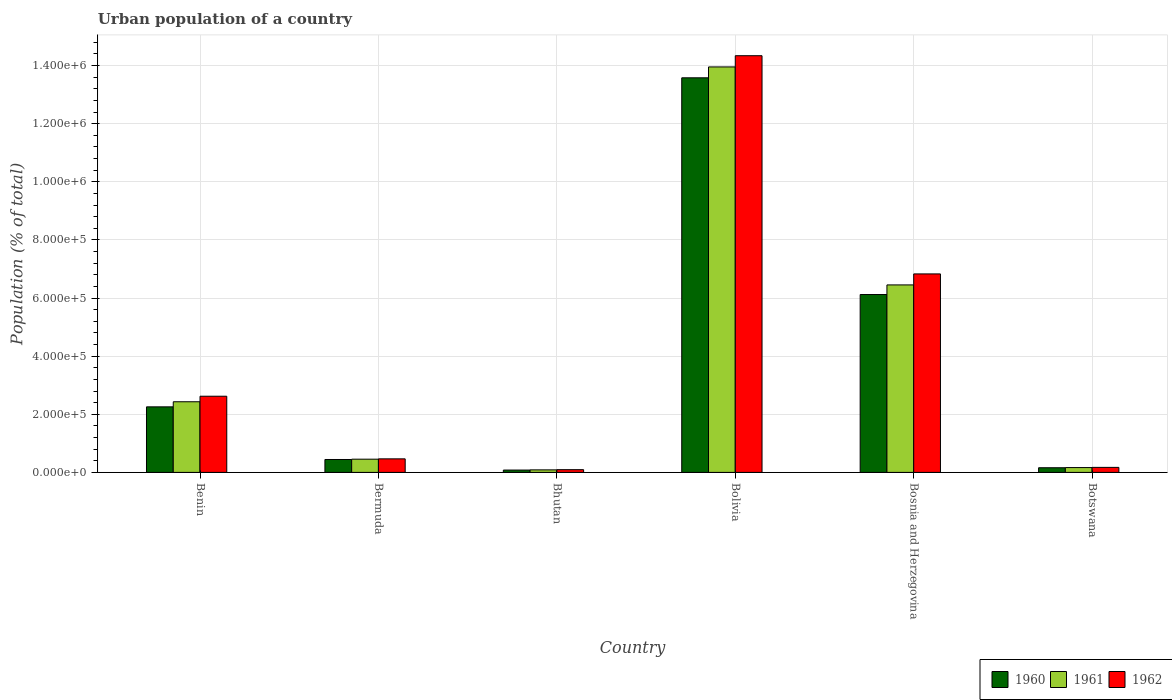Are the number of bars per tick equal to the number of legend labels?
Your answer should be very brief. Yes. Are the number of bars on each tick of the X-axis equal?
Offer a terse response. Yes. What is the label of the 5th group of bars from the left?
Your response must be concise. Bosnia and Herzegovina. In how many cases, is the number of bars for a given country not equal to the number of legend labels?
Provide a succinct answer. 0. What is the urban population in 1962 in Bhutan?
Keep it short and to the point. 9386. Across all countries, what is the maximum urban population in 1961?
Your answer should be compact. 1.40e+06. Across all countries, what is the minimum urban population in 1962?
Give a very brief answer. 9386. In which country was the urban population in 1960 maximum?
Ensure brevity in your answer.  Bolivia. In which country was the urban population in 1962 minimum?
Offer a terse response. Bhutan. What is the total urban population in 1961 in the graph?
Your answer should be compact. 2.35e+06. What is the difference between the urban population in 1962 in Bermuda and that in Botswana?
Your answer should be compact. 2.94e+04. What is the difference between the urban population in 1962 in Bolivia and the urban population in 1960 in Bosnia and Herzegovina?
Your answer should be compact. 8.22e+05. What is the average urban population in 1961 per country?
Your response must be concise. 3.92e+05. What is the difference between the urban population of/in 1961 and urban population of/in 1960 in Bolivia?
Make the answer very short. 3.74e+04. What is the ratio of the urban population in 1960 in Bermuda to that in Botswana?
Your answer should be very brief. 2.77. Is the difference between the urban population in 1961 in Benin and Bermuda greater than the difference between the urban population in 1960 in Benin and Bermuda?
Your response must be concise. Yes. What is the difference between the highest and the second highest urban population in 1960?
Offer a very short reply. -1.13e+06. What is the difference between the highest and the lowest urban population in 1961?
Your answer should be compact. 1.39e+06. Is the sum of the urban population in 1961 in Bermuda and Bolivia greater than the maximum urban population in 1960 across all countries?
Provide a succinct answer. Yes. Is it the case that in every country, the sum of the urban population in 1962 and urban population in 1961 is greater than the urban population in 1960?
Your response must be concise. Yes. Are all the bars in the graph horizontal?
Make the answer very short. No. How many countries are there in the graph?
Give a very brief answer. 6. What is the difference between two consecutive major ticks on the Y-axis?
Provide a short and direct response. 2.00e+05. Are the values on the major ticks of Y-axis written in scientific E-notation?
Ensure brevity in your answer.  Yes. Does the graph contain any zero values?
Your response must be concise. No. How many legend labels are there?
Ensure brevity in your answer.  3. What is the title of the graph?
Your response must be concise. Urban population of a country. What is the label or title of the Y-axis?
Keep it short and to the point. Population (% of total). What is the Population (% of total) of 1960 in Benin?
Make the answer very short. 2.26e+05. What is the Population (% of total) of 1961 in Benin?
Make the answer very short. 2.43e+05. What is the Population (% of total) in 1962 in Benin?
Keep it short and to the point. 2.62e+05. What is the Population (% of total) of 1960 in Bermuda?
Offer a terse response. 4.44e+04. What is the Population (% of total) of 1961 in Bermuda?
Make the answer very short. 4.55e+04. What is the Population (% of total) in 1962 in Bermuda?
Make the answer very short. 4.66e+04. What is the Population (% of total) of 1960 in Bhutan?
Ensure brevity in your answer.  8059. What is the Population (% of total) in 1961 in Bhutan?
Keep it short and to the point. 8695. What is the Population (% of total) of 1962 in Bhutan?
Your response must be concise. 9386. What is the Population (% of total) of 1960 in Bolivia?
Keep it short and to the point. 1.36e+06. What is the Population (% of total) in 1961 in Bolivia?
Your answer should be compact. 1.40e+06. What is the Population (% of total) in 1962 in Bolivia?
Provide a succinct answer. 1.43e+06. What is the Population (% of total) in 1960 in Bosnia and Herzegovina?
Ensure brevity in your answer.  6.12e+05. What is the Population (% of total) in 1961 in Bosnia and Herzegovina?
Provide a short and direct response. 6.45e+05. What is the Population (% of total) in 1962 in Bosnia and Herzegovina?
Make the answer very short. 6.83e+05. What is the Population (% of total) in 1960 in Botswana?
Your response must be concise. 1.60e+04. What is the Population (% of total) of 1961 in Botswana?
Offer a very short reply. 1.66e+04. What is the Population (% of total) in 1962 in Botswana?
Offer a terse response. 1.72e+04. Across all countries, what is the maximum Population (% of total) of 1960?
Provide a succinct answer. 1.36e+06. Across all countries, what is the maximum Population (% of total) of 1961?
Provide a succinct answer. 1.40e+06. Across all countries, what is the maximum Population (% of total) of 1962?
Make the answer very short. 1.43e+06. Across all countries, what is the minimum Population (% of total) of 1960?
Provide a short and direct response. 8059. Across all countries, what is the minimum Population (% of total) in 1961?
Offer a terse response. 8695. Across all countries, what is the minimum Population (% of total) in 1962?
Offer a terse response. 9386. What is the total Population (% of total) in 1960 in the graph?
Make the answer very short. 2.26e+06. What is the total Population (% of total) in 1961 in the graph?
Ensure brevity in your answer.  2.35e+06. What is the total Population (% of total) of 1962 in the graph?
Offer a very short reply. 2.45e+06. What is the difference between the Population (% of total) in 1960 in Benin and that in Bermuda?
Your answer should be very brief. 1.81e+05. What is the difference between the Population (% of total) of 1961 in Benin and that in Bermuda?
Provide a short and direct response. 1.98e+05. What is the difference between the Population (% of total) in 1962 in Benin and that in Bermuda?
Make the answer very short. 2.15e+05. What is the difference between the Population (% of total) of 1960 in Benin and that in Bhutan?
Ensure brevity in your answer.  2.17e+05. What is the difference between the Population (% of total) of 1961 in Benin and that in Bhutan?
Offer a terse response. 2.34e+05. What is the difference between the Population (% of total) of 1962 in Benin and that in Bhutan?
Provide a succinct answer. 2.53e+05. What is the difference between the Population (% of total) in 1960 in Benin and that in Bolivia?
Provide a succinct answer. -1.13e+06. What is the difference between the Population (% of total) of 1961 in Benin and that in Bolivia?
Give a very brief answer. -1.15e+06. What is the difference between the Population (% of total) of 1962 in Benin and that in Bolivia?
Provide a short and direct response. -1.17e+06. What is the difference between the Population (% of total) of 1960 in Benin and that in Bosnia and Herzegovina?
Your answer should be compact. -3.87e+05. What is the difference between the Population (% of total) of 1961 in Benin and that in Bosnia and Herzegovina?
Your answer should be very brief. -4.02e+05. What is the difference between the Population (% of total) of 1962 in Benin and that in Bosnia and Herzegovina?
Keep it short and to the point. -4.21e+05. What is the difference between the Population (% of total) in 1960 in Benin and that in Botswana?
Your answer should be very brief. 2.09e+05. What is the difference between the Population (% of total) of 1961 in Benin and that in Botswana?
Your answer should be compact. 2.26e+05. What is the difference between the Population (% of total) of 1962 in Benin and that in Botswana?
Make the answer very short. 2.45e+05. What is the difference between the Population (% of total) in 1960 in Bermuda and that in Bhutan?
Provide a short and direct response. 3.63e+04. What is the difference between the Population (% of total) of 1961 in Bermuda and that in Bhutan?
Ensure brevity in your answer.  3.68e+04. What is the difference between the Population (% of total) in 1962 in Bermuda and that in Bhutan?
Give a very brief answer. 3.72e+04. What is the difference between the Population (% of total) in 1960 in Bermuda and that in Bolivia?
Provide a succinct answer. -1.31e+06. What is the difference between the Population (% of total) in 1961 in Bermuda and that in Bolivia?
Your answer should be very brief. -1.35e+06. What is the difference between the Population (% of total) of 1962 in Bermuda and that in Bolivia?
Your response must be concise. -1.39e+06. What is the difference between the Population (% of total) in 1960 in Bermuda and that in Bosnia and Herzegovina?
Provide a succinct answer. -5.68e+05. What is the difference between the Population (% of total) in 1961 in Bermuda and that in Bosnia and Herzegovina?
Your response must be concise. -6.00e+05. What is the difference between the Population (% of total) of 1962 in Bermuda and that in Bosnia and Herzegovina?
Offer a terse response. -6.36e+05. What is the difference between the Population (% of total) of 1960 in Bermuda and that in Botswana?
Keep it short and to the point. 2.84e+04. What is the difference between the Population (% of total) of 1961 in Bermuda and that in Botswana?
Your answer should be very brief. 2.89e+04. What is the difference between the Population (% of total) of 1962 in Bermuda and that in Botswana?
Make the answer very short. 2.94e+04. What is the difference between the Population (% of total) of 1960 in Bhutan and that in Bolivia?
Your answer should be very brief. -1.35e+06. What is the difference between the Population (% of total) of 1961 in Bhutan and that in Bolivia?
Your answer should be very brief. -1.39e+06. What is the difference between the Population (% of total) in 1962 in Bhutan and that in Bolivia?
Ensure brevity in your answer.  -1.42e+06. What is the difference between the Population (% of total) in 1960 in Bhutan and that in Bosnia and Herzegovina?
Provide a succinct answer. -6.04e+05. What is the difference between the Population (% of total) of 1961 in Bhutan and that in Bosnia and Herzegovina?
Your response must be concise. -6.36e+05. What is the difference between the Population (% of total) of 1962 in Bhutan and that in Bosnia and Herzegovina?
Give a very brief answer. -6.74e+05. What is the difference between the Population (% of total) in 1960 in Bhutan and that in Botswana?
Make the answer very short. -7976. What is the difference between the Population (% of total) in 1961 in Bhutan and that in Botswana?
Your answer should be very brief. -7923. What is the difference between the Population (% of total) in 1962 in Bhutan and that in Botswana?
Your response must be concise. -7851. What is the difference between the Population (% of total) in 1960 in Bolivia and that in Bosnia and Herzegovina?
Offer a terse response. 7.46e+05. What is the difference between the Population (% of total) in 1961 in Bolivia and that in Bosnia and Herzegovina?
Your answer should be compact. 7.50e+05. What is the difference between the Population (% of total) in 1962 in Bolivia and that in Bosnia and Herzegovina?
Your answer should be very brief. 7.51e+05. What is the difference between the Population (% of total) of 1960 in Bolivia and that in Botswana?
Your answer should be very brief. 1.34e+06. What is the difference between the Population (% of total) of 1961 in Bolivia and that in Botswana?
Your answer should be compact. 1.38e+06. What is the difference between the Population (% of total) in 1962 in Bolivia and that in Botswana?
Keep it short and to the point. 1.42e+06. What is the difference between the Population (% of total) of 1960 in Bosnia and Herzegovina and that in Botswana?
Keep it short and to the point. 5.96e+05. What is the difference between the Population (% of total) in 1961 in Bosnia and Herzegovina and that in Botswana?
Your response must be concise. 6.29e+05. What is the difference between the Population (% of total) in 1962 in Bosnia and Herzegovina and that in Botswana?
Ensure brevity in your answer.  6.66e+05. What is the difference between the Population (% of total) of 1960 in Benin and the Population (% of total) of 1961 in Bermuda?
Make the answer very short. 1.80e+05. What is the difference between the Population (% of total) of 1960 in Benin and the Population (% of total) of 1962 in Bermuda?
Provide a short and direct response. 1.79e+05. What is the difference between the Population (% of total) of 1961 in Benin and the Population (% of total) of 1962 in Bermuda?
Offer a very short reply. 1.96e+05. What is the difference between the Population (% of total) of 1960 in Benin and the Population (% of total) of 1961 in Bhutan?
Offer a very short reply. 2.17e+05. What is the difference between the Population (% of total) in 1960 in Benin and the Population (% of total) in 1962 in Bhutan?
Provide a short and direct response. 2.16e+05. What is the difference between the Population (% of total) of 1961 in Benin and the Population (% of total) of 1962 in Bhutan?
Make the answer very short. 2.34e+05. What is the difference between the Population (% of total) of 1960 in Benin and the Population (% of total) of 1961 in Bolivia?
Make the answer very short. -1.17e+06. What is the difference between the Population (% of total) in 1960 in Benin and the Population (% of total) in 1962 in Bolivia?
Keep it short and to the point. -1.21e+06. What is the difference between the Population (% of total) in 1961 in Benin and the Population (% of total) in 1962 in Bolivia?
Give a very brief answer. -1.19e+06. What is the difference between the Population (% of total) of 1960 in Benin and the Population (% of total) of 1961 in Bosnia and Herzegovina?
Your answer should be very brief. -4.20e+05. What is the difference between the Population (% of total) in 1960 in Benin and the Population (% of total) in 1962 in Bosnia and Herzegovina?
Keep it short and to the point. -4.57e+05. What is the difference between the Population (% of total) of 1961 in Benin and the Population (% of total) of 1962 in Bosnia and Herzegovina?
Keep it short and to the point. -4.40e+05. What is the difference between the Population (% of total) in 1960 in Benin and the Population (% of total) in 1961 in Botswana?
Your answer should be very brief. 2.09e+05. What is the difference between the Population (% of total) in 1960 in Benin and the Population (% of total) in 1962 in Botswana?
Offer a very short reply. 2.08e+05. What is the difference between the Population (% of total) in 1961 in Benin and the Population (% of total) in 1962 in Botswana?
Provide a succinct answer. 2.26e+05. What is the difference between the Population (% of total) of 1960 in Bermuda and the Population (% of total) of 1961 in Bhutan?
Give a very brief answer. 3.57e+04. What is the difference between the Population (% of total) in 1960 in Bermuda and the Population (% of total) in 1962 in Bhutan?
Make the answer very short. 3.50e+04. What is the difference between the Population (% of total) of 1961 in Bermuda and the Population (% of total) of 1962 in Bhutan?
Your response must be concise. 3.61e+04. What is the difference between the Population (% of total) in 1960 in Bermuda and the Population (% of total) in 1961 in Bolivia?
Your answer should be compact. -1.35e+06. What is the difference between the Population (% of total) of 1960 in Bermuda and the Population (% of total) of 1962 in Bolivia?
Keep it short and to the point. -1.39e+06. What is the difference between the Population (% of total) of 1961 in Bermuda and the Population (% of total) of 1962 in Bolivia?
Make the answer very short. -1.39e+06. What is the difference between the Population (% of total) in 1960 in Bermuda and the Population (% of total) in 1961 in Bosnia and Herzegovina?
Give a very brief answer. -6.01e+05. What is the difference between the Population (% of total) in 1960 in Bermuda and the Population (% of total) in 1962 in Bosnia and Herzegovina?
Offer a terse response. -6.39e+05. What is the difference between the Population (% of total) in 1961 in Bermuda and the Population (% of total) in 1962 in Bosnia and Herzegovina?
Ensure brevity in your answer.  -6.37e+05. What is the difference between the Population (% of total) in 1960 in Bermuda and the Population (% of total) in 1961 in Botswana?
Provide a succinct answer. 2.78e+04. What is the difference between the Population (% of total) in 1960 in Bermuda and the Population (% of total) in 1962 in Botswana?
Make the answer very short. 2.72e+04. What is the difference between the Population (% of total) in 1961 in Bermuda and the Population (% of total) in 1962 in Botswana?
Make the answer very short. 2.83e+04. What is the difference between the Population (% of total) in 1960 in Bhutan and the Population (% of total) in 1961 in Bolivia?
Offer a very short reply. -1.39e+06. What is the difference between the Population (% of total) of 1960 in Bhutan and the Population (% of total) of 1962 in Bolivia?
Make the answer very short. -1.43e+06. What is the difference between the Population (% of total) in 1961 in Bhutan and the Population (% of total) in 1962 in Bolivia?
Provide a short and direct response. -1.43e+06. What is the difference between the Population (% of total) in 1960 in Bhutan and the Population (% of total) in 1961 in Bosnia and Herzegovina?
Offer a very short reply. -6.37e+05. What is the difference between the Population (% of total) in 1960 in Bhutan and the Population (% of total) in 1962 in Bosnia and Herzegovina?
Make the answer very short. -6.75e+05. What is the difference between the Population (% of total) of 1961 in Bhutan and the Population (% of total) of 1962 in Bosnia and Herzegovina?
Your answer should be very brief. -6.74e+05. What is the difference between the Population (% of total) of 1960 in Bhutan and the Population (% of total) of 1961 in Botswana?
Give a very brief answer. -8559. What is the difference between the Population (% of total) of 1960 in Bhutan and the Population (% of total) of 1962 in Botswana?
Ensure brevity in your answer.  -9178. What is the difference between the Population (% of total) in 1961 in Bhutan and the Population (% of total) in 1962 in Botswana?
Keep it short and to the point. -8542. What is the difference between the Population (% of total) of 1960 in Bolivia and the Population (% of total) of 1961 in Bosnia and Herzegovina?
Your response must be concise. 7.13e+05. What is the difference between the Population (% of total) in 1960 in Bolivia and the Population (% of total) in 1962 in Bosnia and Herzegovina?
Your response must be concise. 6.75e+05. What is the difference between the Population (% of total) of 1961 in Bolivia and the Population (% of total) of 1962 in Bosnia and Herzegovina?
Your answer should be compact. 7.12e+05. What is the difference between the Population (% of total) in 1960 in Bolivia and the Population (% of total) in 1961 in Botswana?
Provide a succinct answer. 1.34e+06. What is the difference between the Population (% of total) of 1960 in Bolivia and the Population (% of total) of 1962 in Botswana?
Offer a very short reply. 1.34e+06. What is the difference between the Population (% of total) of 1961 in Bolivia and the Population (% of total) of 1962 in Botswana?
Offer a terse response. 1.38e+06. What is the difference between the Population (% of total) of 1960 in Bosnia and Herzegovina and the Population (% of total) of 1961 in Botswana?
Offer a terse response. 5.95e+05. What is the difference between the Population (% of total) of 1960 in Bosnia and Herzegovina and the Population (% of total) of 1962 in Botswana?
Give a very brief answer. 5.95e+05. What is the difference between the Population (% of total) of 1961 in Bosnia and Herzegovina and the Population (% of total) of 1962 in Botswana?
Provide a short and direct response. 6.28e+05. What is the average Population (% of total) of 1960 per country?
Your answer should be compact. 3.77e+05. What is the average Population (% of total) in 1961 per country?
Keep it short and to the point. 3.92e+05. What is the average Population (% of total) in 1962 per country?
Provide a succinct answer. 4.09e+05. What is the difference between the Population (% of total) in 1960 and Population (% of total) in 1961 in Benin?
Provide a short and direct response. -1.75e+04. What is the difference between the Population (% of total) of 1960 and Population (% of total) of 1962 in Benin?
Offer a very short reply. -3.66e+04. What is the difference between the Population (% of total) of 1961 and Population (% of total) of 1962 in Benin?
Offer a terse response. -1.90e+04. What is the difference between the Population (% of total) in 1960 and Population (% of total) in 1961 in Bermuda?
Your answer should be very brief. -1100. What is the difference between the Population (% of total) of 1960 and Population (% of total) of 1962 in Bermuda?
Provide a short and direct response. -2200. What is the difference between the Population (% of total) in 1961 and Population (% of total) in 1962 in Bermuda?
Offer a terse response. -1100. What is the difference between the Population (% of total) of 1960 and Population (% of total) of 1961 in Bhutan?
Offer a very short reply. -636. What is the difference between the Population (% of total) in 1960 and Population (% of total) in 1962 in Bhutan?
Give a very brief answer. -1327. What is the difference between the Population (% of total) of 1961 and Population (% of total) of 1962 in Bhutan?
Provide a short and direct response. -691. What is the difference between the Population (% of total) in 1960 and Population (% of total) in 1961 in Bolivia?
Your answer should be very brief. -3.74e+04. What is the difference between the Population (% of total) of 1960 and Population (% of total) of 1962 in Bolivia?
Offer a terse response. -7.60e+04. What is the difference between the Population (% of total) of 1961 and Population (% of total) of 1962 in Bolivia?
Your response must be concise. -3.86e+04. What is the difference between the Population (% of total) of 1960 and Population (% of total) of 1961 in Bosnia and Herzegovina?
Give a very brief answer. -3.31e+04. What is the difference between the Population (% of total) in 1960 and Population (% of total) in 1962 in Bosnia and Herzegovina?
Your response must be concise. -7.09e+04. What is the difference between the Population (% of total) of 1961 and Population (% of total) of 1962 in Bosnia and Herzegovina?
Provide a succinct answer. -3.78e+04. What is the difference between the Population (% of total) in 1960 and Population (% of total) in 1961 in Botswana?
Your answer should be compact. -583. What is the difference between the Population (% of total) of 1960 and Population (% of total) of 1962 in Botswana?
Provide a short and direct response. -1202. What is the difference between the Population (% of total) in 1961 and Population (% of total) in 1962 in Botswana?
Give a very brief answer. -619. What is the ratio of the Population (% of total) of 1960 in Benin to that in Bermuda?
Your answer should be very brief. 5.08. What is the ratio of the Population (% of total) in 1961 in Benin to that in Bermuda?
Give a very brief answer. 5.34. What is the ratio of the Population (% of total) in 1962 in Benin to that in Bermuda?
Keep it short and to the point. 5.62. What is the ratio of the Population (% of total) in 1960 in Benin to that in Bhutan?
Provide a short and direct response. 27.99. What is the ratio of the Population (% of total) of 1961 in Benin to that in Bhutan?
Ensure brevity in your answer.  27.95. What is the ratio of the Population (% of total) of 1962 in Benin to that in Bhutan?
Your answer should be very brief. 27.92. What is the ratio of the Population (% of total) in 1960 in Benin to that in Bolivia?
Make the answer very short. 0.17. What is the ratio of the Population (% of total) in 1961 in Benin to that in Bolivia?
Give a very brief answer. 0.17. What is the ratio of the Population (% of total) in 1962 in Benin to that in Bolivia?
Ensure brevity in your answer.  0.18. What is the ratio of the Population (% of total) of 1960 in Benin to that in Bosnia and Herzegovina?
Offer a very short reply. 0.37. What is the ratio of the Population (% of total) of 1961 in Benin to that in Bosnia and Herzegovina?
Your response must be concise. 0.38. What is the ratio of the Population (% of total) in 1962 in Benin to that in Bosnia and Herzegovina?
Offer a terse response. 0.38. What is the ratio of the Population (% of total) in 1960 in Benin to that in Botswana?
Provide a short and direct response. 14.06. What is the ratio of the Population (% of total) in 1961 in Benin to that in Botswana?
Offer a very short reply. 14.63. What is the ratio of the Population (% of total) in 1962 in Benin to that in Botswana?
Make the answer very short. 15.21. What is the ratio of the Population (% of total) of 1960 in Bermuda to that in Bhutan?
Give a very brief answer. 5.51. What is the ratio of the Population (% of total) of 1961 in Bermuda to that in Bhutan?
Your answer should be very brief. 5.23. What is the ratio of the Population (% of total) of 1962 in Bermuda to that in Bhutan?
Your response must be concise. 4.96. What is the ratio of the Population (% of total) of 1960 in Bermuda to that in Bolivia?
Keep it short and to the point. 0.03. What is the ratio of the Population (% of total) in 1961 in Bermuda to that in Bolivia?
Ensure brevity in your answer.  0.03. What is the ratio of the Population (% of total) in 1962 in Bermuda to that in Bolivia?
Make the answer very short. 0.03. What is the ratio of the Population (% of total) in 1960 in Bermuda to that in Bosnia and Herzegovina?
Provide a succinct answer. 0.07. What is the ratio of the Population (% of total) of 1961 in Bermuda to that in Bosnia and Herzegovina?
Your response must be concise. 0.07. What is the ratio of the Population (% of total) in 1962 in Bermuda to that in Bosnia and Herzegovina?
Give a very brief answer. 0.07. What is the ratio of the Population (% of total) in 1960 in Bermuda to that in Botswana?
Your answer should be compact. 2.77. What is the ratio of the Population (% of total) in 1961 in Bermuda to that in Botswana?
Your response must be concise. 2.74. What is the ratio of the Population (% of total) in 1962 in Bermuda to that in Botswana?
Keep it short and to the point. 2.7. What is the ratio of the Population (% of total) of 1960 in Bhutan to that in Bolivia?
Provide a succinct answer. 0.01. What is the ratio of the Population (% of total) of 1961 in Bhutan to that in Bolivia?
Your answer should be very brief. 0.01. What is the ratio of the Population (% of total) in 1962 in Bhutan to that in Bolivia?
Offer a very short reply. 0.01. What is the ratio of the Population (% of total) of 1960 in Bhutan to that in Bosnia and Herzegovina?
Your response must be concise. 0.01. What is the ratio of the Population (% of total) of 1961 in Bhutan to that in Bosnia and Herzegovina?
Provide a succinct answer. 0.01. What is the ratio of the Population (% of total) in 1962 in Bhutan to that in Bosnia and Herzegovina?
Offer a very short reply. 0.01. What is the ratio of the Population (% of total) of 1960 in Bhutan to that in Botswana?
Offer a terse response. 0.5. What is the ratio of the Population (% of total) in 1961 in Bhutan to that in Botswana?
Give a very brief answer. 0.52. What is the ratio of the Population (% of total) of 1962 in Bhutan to that in Botswana?
Your answer should be very brief. 0.54. What is the ratio of the Population (% of total) in 1960 in Bolivia to that in Bosnia and Herzegovina?
Your answer should be very brief. 2.22. What is the ratio of the Population (% of total) of 1961 in Bolivia to that in Bosnia and Herzegovina?
Your response must be concise. 2.16. What is the ratio of the Population (% of total) of 1962 in Bolivia to that in Bosnia and Herzegovina?
Give a very brief answer. 2.1. What is the ratio of the Population (% of total) in 1960 in Bolivia to that in Botswana?
Ensure brevity in your answer.  84.68. What is the ratio of the Population (% of total) of 1961 in Bolivia to that in Botswana?
Your response must be concise. 83.96. What is the ratio of the Population (% of total) of 1962 in Bolivia to that in Botswana?
Offer a terse response. 83.18. What is the ratio of the Population (% of total) in 1960 in Bosnia and Herzegovina to that in Botswana?
Offer a terse response. 38.17. What is the ratio of the Population (% of total) in 1961 in Bosnia and Herzegovina to that in Botswana?
Give a very brief answer. 38.82. What is the ratio of the Population (% of total) in 1962 in Bosnia and Herzegovina to that in Botswana?
Give a very brief answer. 39.62. What is the difference between the highest and the second highest Population (% of total) of 1960?
Make the answer very short. 7.46e+05. What is the difference between the highest and the second highest Population (% of total) of 1961?
Your answer should be compact. 7.50e+05. What is the difference between the highest and the second highest Population (% of total) in 1962?
Ensure brevity in your answer.  7.51e+05. What is the difference between the highest and the lowest Population (% of total) in 1960?
Provide a succinct answer. 1.35e+06. What is the difference between the highest and the lowest Population (% of total) of 1961?
Give a very brief answer. 1.39e+06. What is the difference between the highest and the lowest Population (% of total) of 1962?
Offer a very short reply. 1.42e+06. 